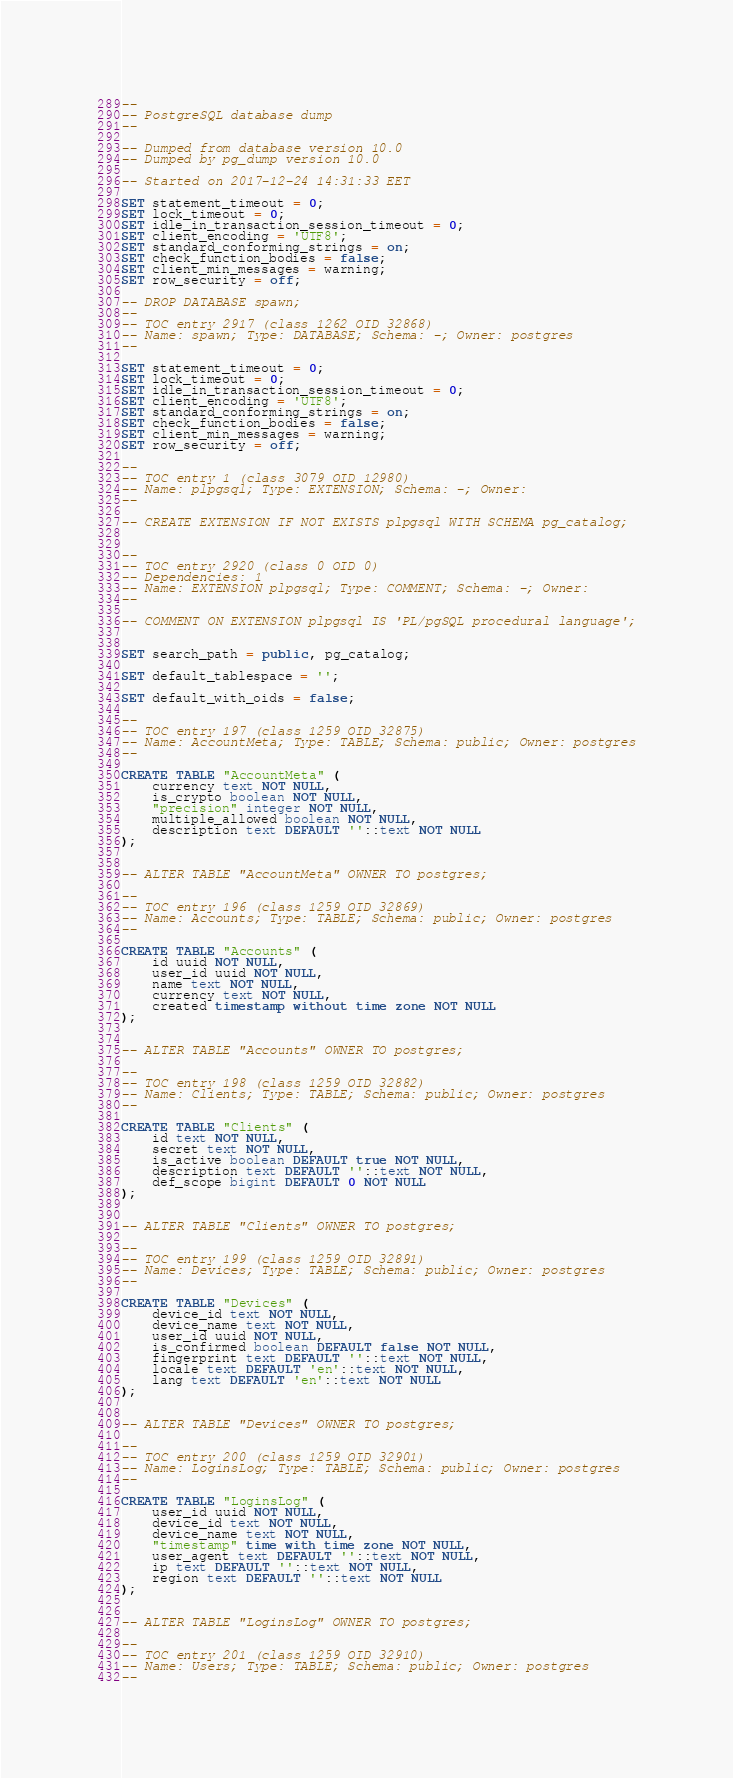Convert code to text. <code><loc_0><loc_0><loc_500><loc_500><_SQL_>--
-- PostgreSQL database dump
--

-- Dumped from database version 10.0
-- Dumped by pg_dump version 10.0

-- Started on 2017-12-24 14:31:33 EET

SET statement_timeout = 0;
SET lock_timeout = 0;
SET idle_in_transaction_session_timeout = 0;
SET client_encoding = 'UTF8';
SET standard_conforming_strings = on;
SET check_function_bodies = false;
SET client_min_messages = warning;
SET row_security = off;

-- DROP DATABASE spawn;
--
-- TOC entry 2917 (class 1262 OID 32868)
-- Name: spawn; Type: DATABASE; Schema: -; Owner: postgres
--

SET statement_timeout = 0;
SET lock_timeout = 0;
SET idle_in_transaction_session_timeout = 0;
SET client_encoding = 'UTF8';
SET standard_conforming_strings = on;
SET check_function_bodies = false;
SET client_min_messages = warning;
SET row_security = off;

--
-- TOC entry 1 (class 3079 OID 12980)
-- Name: plpgsql; Type: EXTENSION; Schema: -; Owner: 
--

-- CREATE EXTENSION IF NOT EXISTS plpgsql WITH SCHEMA pg_catalog;


--
-- TOC entry 2920 (class 0 OID 0)
-- Dependencies: 1
-- Name: EXTENSION plpgsql; Type: COMMENT; Schema: -; Owner: 
--

-- COMMENT ON EXTENSION plpgsql IS 'PL/pgSQL procedural language';


SET search_path = public, pg_catalog;

SET default_tablespace = '';

SET default_with_oids = false;

--
-- TOC entry 197 (class 1259 OID 32875)
-- Name: AccountMeta; Type: TABLE; Schema: public; Owner: postgres
--

CREATE TABLE "AccountMeta" (
    currency text NOT NULL,
    is_crypto boolean NOT NULL,
    "precision" integer NOT NULL,
    multiple_allowed boolean NOT NULL,
    description text DEFAULT ''::text NOT NULL
);


-- ALTER TABLE "AccountMeta" OWNER TO postgres;

--
-- TOC entry 196 (class 1259 OID 32869)
-- Name: Accounts; Type: TABLE; Schema: public; Owner: postgres
--

CREATE TABLE "Accounts" (
    id uuid NOT NULL,
    user_id uuid NOT NULL,
    name text NOT NULL,
    currency text NOT NULL,
    created timestamp without time zone NOT NULL
);


-- ALTER TABLE "Accounts" OWNER TO postgres;

--
-- TOC entry 198 (class 1259 OID 32882)
-- Name: Clients; Type: TABLE; Schema: public; Owner: postgres
--

CREATE TABLE "Clients" (
    id text NOT NULL,
    secret text NOT NULL,
    is_active boolean DEFAULT true NOT NULL,
    description text DEFAULT ''::text NOT NULL,
    def_scope bigint DEFAULT 0 NOT NULL
);


-- ALTER TABLE "Clients" OWNER TO postgres;

--
-- TOC entry 199 (class 1259 OID 32891)
-- Name: Devices; Type: TABLE; Schema: public; Owner: postgres
--

CREATE TABLE "Devices" (
    device_id text NOT NULL,
    device_name text NOT NULL,
    user_id uuid NOT NULL,
    is_confirmed boolean DEFAULT false NOT NULL,
    fingerprint text DEFAULT ''::text NOT NULL,
    locale text DEFAULT 'en'::text NOT NULL,
    lang text DEFAULT 'en'::text NOT NULL
);


-- ALTER TABLE "Devices" OWNER TO postgres;

--
-- TOC entry 200 (class 1259 OID 32901)
-- Name: LoginsLog; Type: TABLE; Schema: public; Owner: postgres
--

CREATE TABLE "LoginsLog" (
    user_id uuid NOT NULL,
    device_id text NOT NULL,
    device_name text NOT NULL,
    "timestamp" time with time zone NOT NULL,
    user_agent text DEFAULT ''::text NOT NULL,
    ip text DEFAULT ''::text NOT NULL,
    region text DEFAULT ''::text NOT NULL
);


-- ALTER TABLE "LoginsLog" OWNER TO postgres;

--
-- TOC entry 201 (class 1259 OID 32910)
-- Name: Users; Type: TABLE; Schema: public; Owner: postgres
--
</code> 